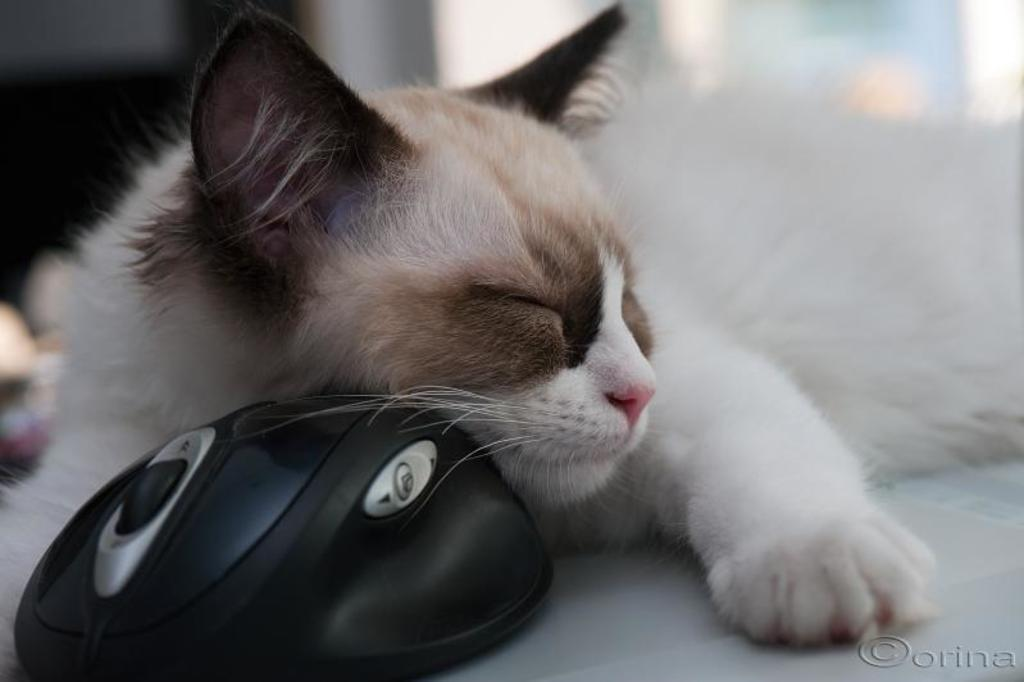What type of animal can be seen in the image? There is a cat in the image. What is the cat doing in the image? The cat is sleeping. Can you describe the color of the cat? The cat is in brown and white color. What other animal is present in the image? There is a mouse in the image. What is the color of the mouse? The mouse is in black color. What type of plantation can be seen in the image? There is no plantation present in the image; it features a cat and a mouse. 